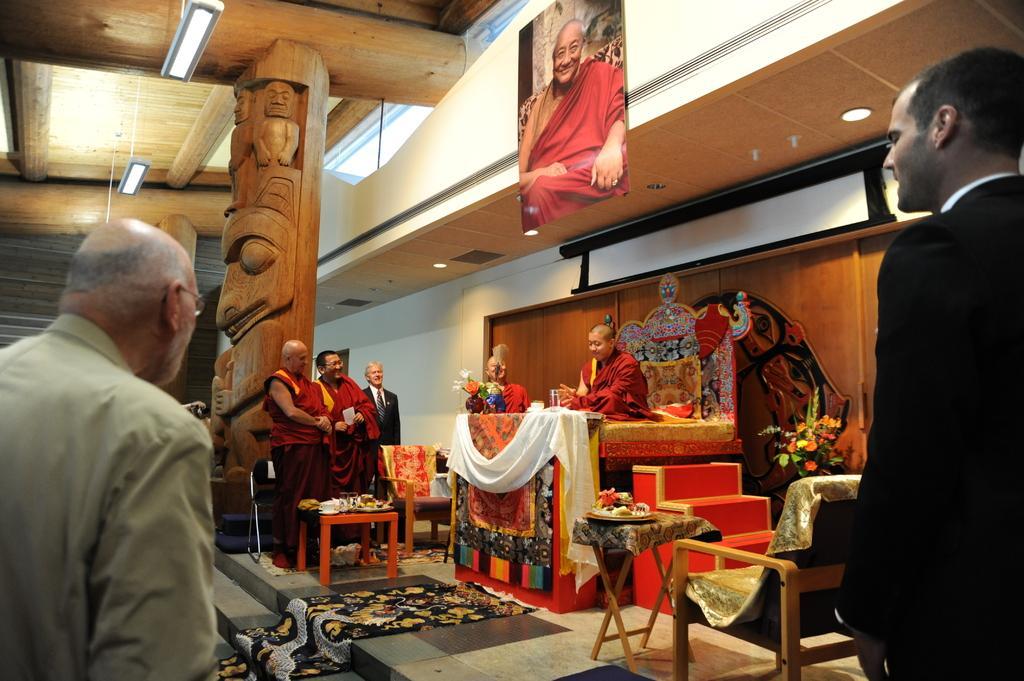How would you summarize this image in a sentence or two? In this image there are group of persons standing and sitting. In the center there is mat on the floor and there are tables, sofas and there are flowers. On the top there is a frame hanging on the wall and there are lights and there is a pillar. On the pillar there are sculptures. 